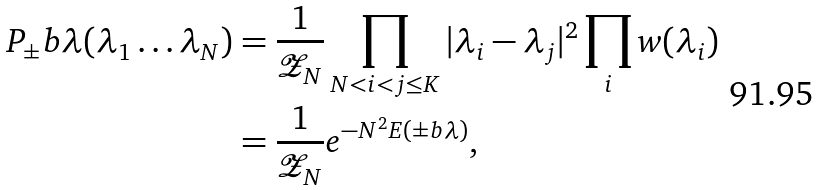<formula> <loc_0><loc_0><loc_500><loc_500>P _ { \pm } b { \lambda } ( \lambda _ { 1 } \dots \lambda _ { N } ) & = \frac { 1 } { \mathcal { Z } _ { N } } \prod _ { N < i < j \leq K } | \lambda _ { i } - \lambda _ { j } | ^ { 2 } \prod _ { i } w ( \lambda _ { i } ) \\ & = \frac { 1 } { \mathcal { Z } _ { N } } e ^ { - N ^ { 2 } E ( \pm b { \lambda } ) } ,</formula> 